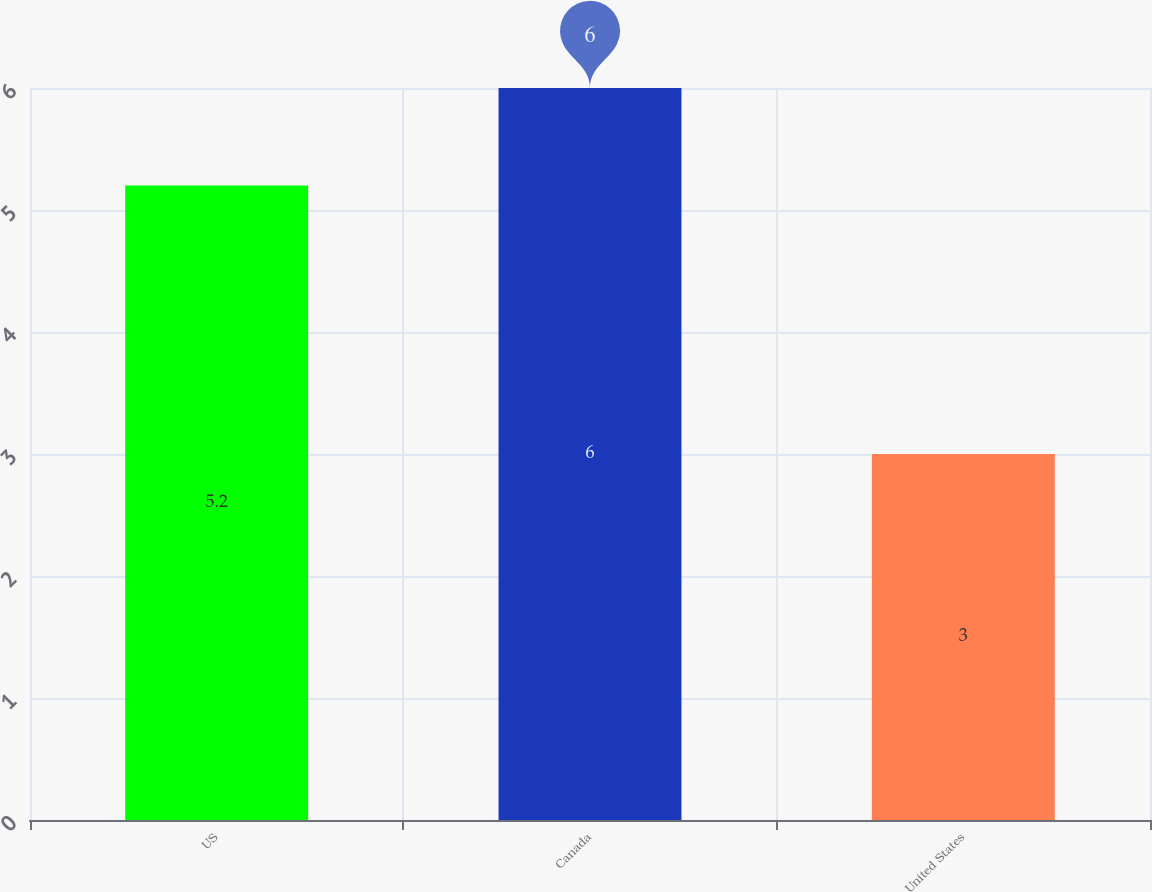Convert chart to OTSL. <chart><loc_0><loc_0><loc_500><loc_500><bar_chart><fcel>US<fcel>Canada<fcel>United States<nl><fcel>5.2<fcel>6<fcel>3<nl></chart> 